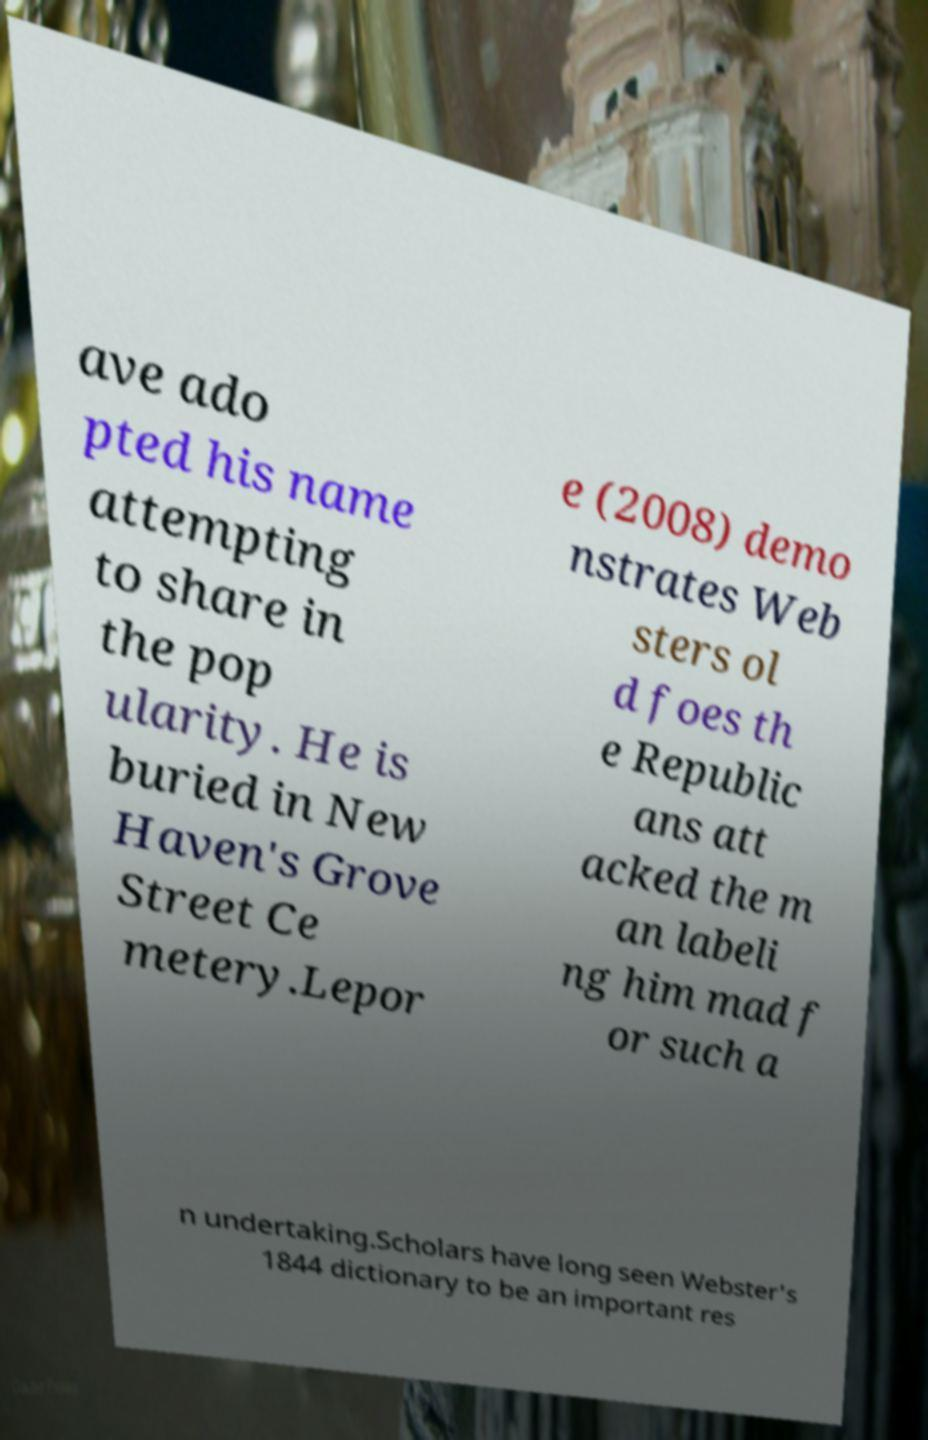What messages or text are displayed in this image? I need them in a readable, typed format. ave ado pted his name attempting to share in the pop ularity. He is buried in New Haven's Grove Street Ce metery.Lepor e (2008) demo nstrates Web sters ol d foes th e Republic ans att acked the m an labeli ng him mad f or such a n undertaking.Scholars have long seen Webster's 1844 dictionary to be an important res 